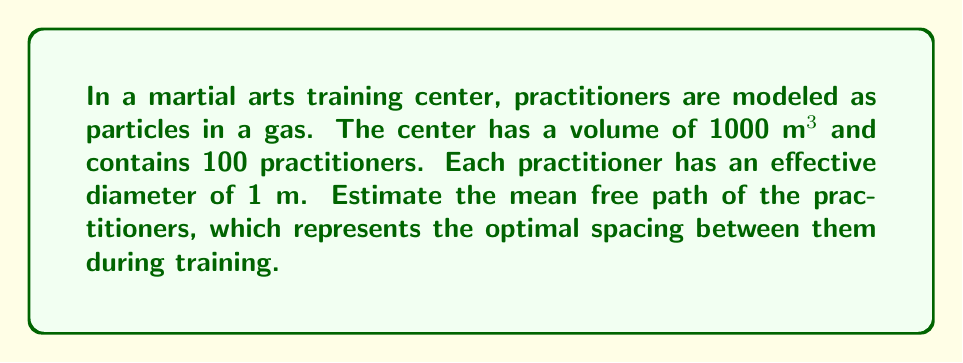Can you answer this question? To solve this problem, we'll use the formula for mean free path in kinetic theory of gases:

$$\lambda = \frac{1}{\sqrt{2}\pi d^2 n}$$

Where:
$\lambda$ = mean free path
$d$ = effective diameter of a particle (practitioner)
$n$ = number density of particles (practitioners per unit volume)

Steps:
1. Calculate the number density $n$:
   $n = \frac{\text{number of practitioners}}{\text{volume}} = \frac{100}{1000 \text{ m}^3} = 0.1 \text{ m}^{-3}$

2. Use the given effective diameter: $d = 1 \text{ m}$

3. Substitute these values into the mean free path formula:
   $$\lambda = \frac{1}{\sqrt{2}\pi (1 \text{ m})^2 (0.1 \text{ m}^{-3})}$$

4. Simplify and calculate:
   $$\lambda = \frac{1}{\sqrt{2}\pi (0.1)} \approx 2.25 \text{ m}$$

This result suggests that the optimal spacing between practitioners in the training center is approximately 2.25 meters.
Answer: $2.25 \text{ m}$ 